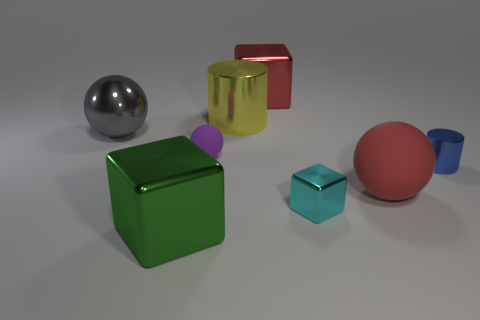Subtract all matte spheres. How many spheres are left? 1 Subtract all cylinders. How many objects are left? 6 Subtract all red blocks. How many blocks are left? 2 Subtract 3 blocks. How many blocks are left? 0 Add 4 red objects. How many red objects exist? 6 Add 1 cyan metallic things. How many objects exist? 9 Subtract 0 purple cubes. How many objects are left? 8 Subtract all blue blocks. Subtract all blue cylinders. How many blocks are left? 3 Subtract all cyan spheres. How many purple cubes are left? 0 Subtract all big green objects. Subtract all green shiny objects. How many objects are left? 6 